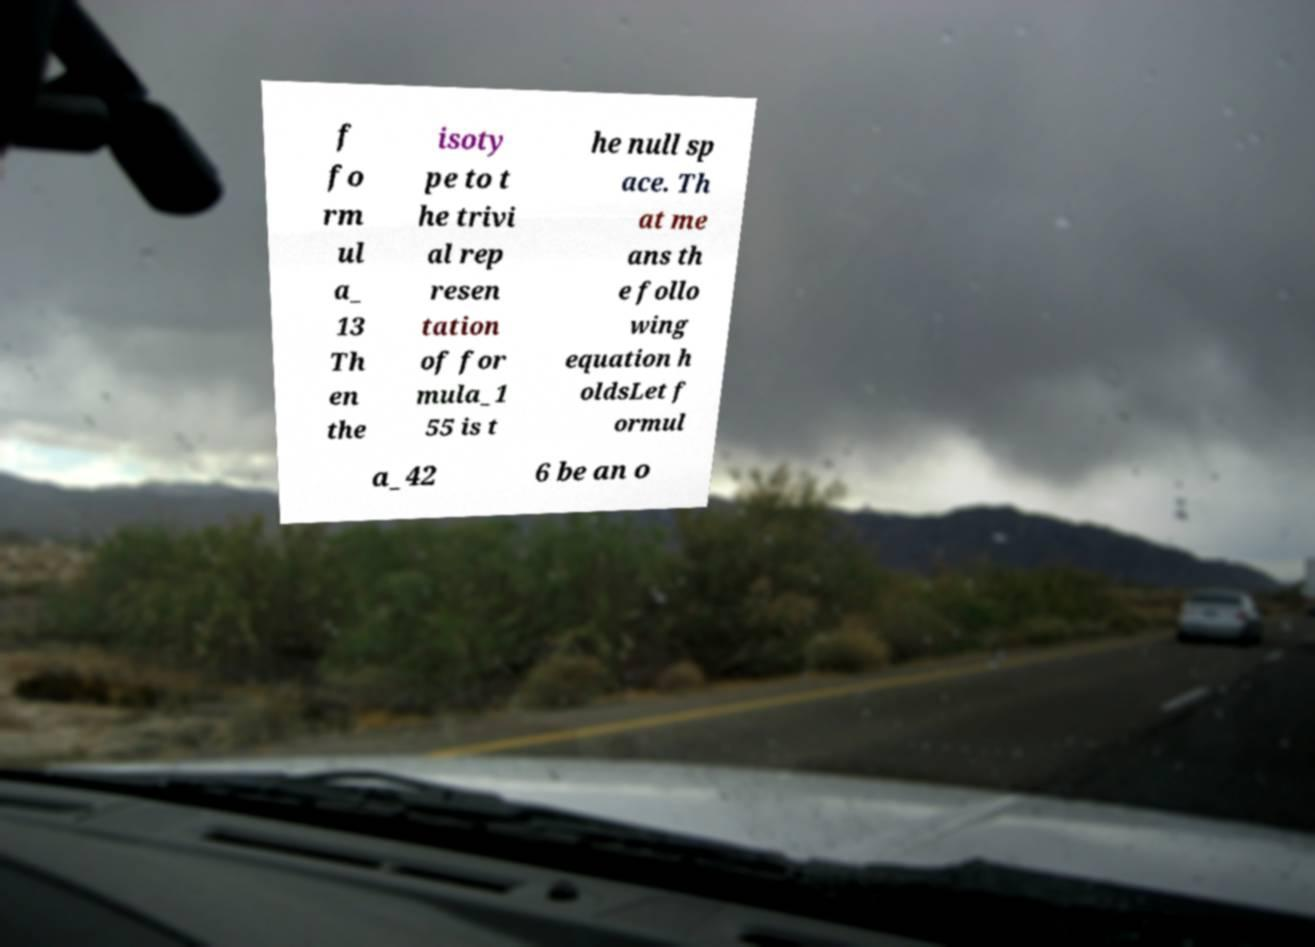For documentation purposes, I need the text within this image transcribed. Could you provide that? f fo rm ul a_ 13 Th en the isoty pe to t he trivi al rep resen tation of for mula_1 55 is t he null sp ace. Th at me ans th e follo wing equation h oldsLet f ormul a_42 6 be an o 